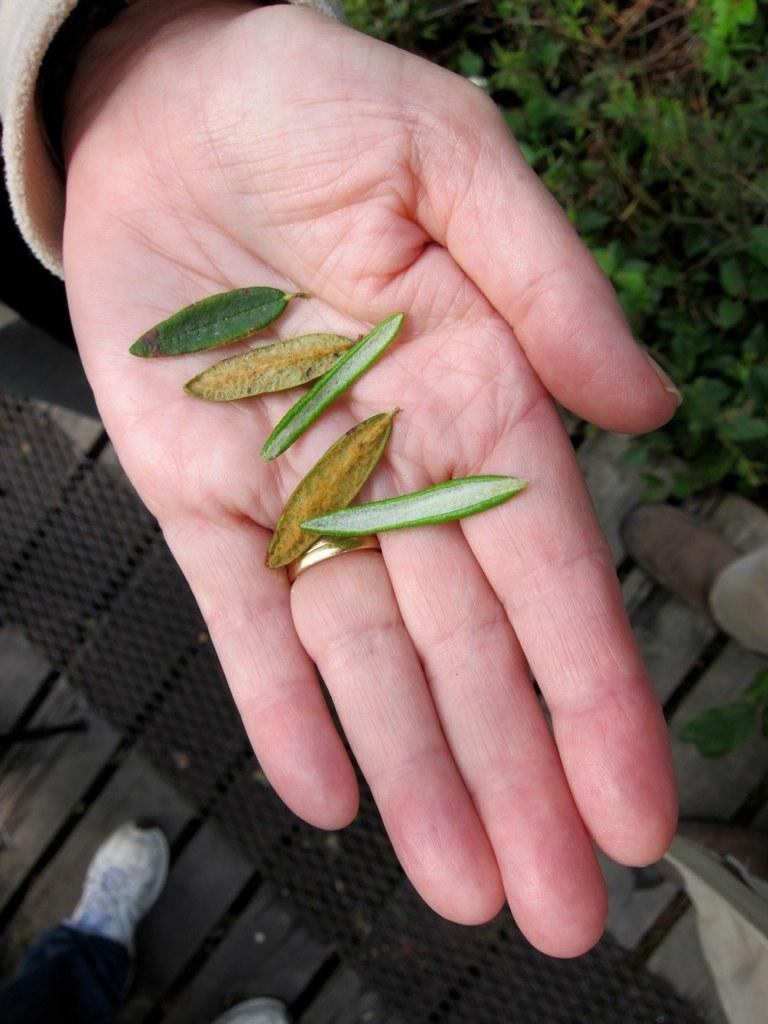What is placed on the person's hand in the center of the image? There are leaves placed on a person's hand in the center of the image. What can be seen at the bottom of the image? There is a walkway at the bottom of the image. What type of vegetation is visible in the image? There is grass visible in the image. Whose legs are visible in the image? A person's legs are visible in the image. What type of flame can be seen burning in the image? There is no flame present in the image. How many snakes are slithering around the person's legs in the image? There are no snakes present in the image. 